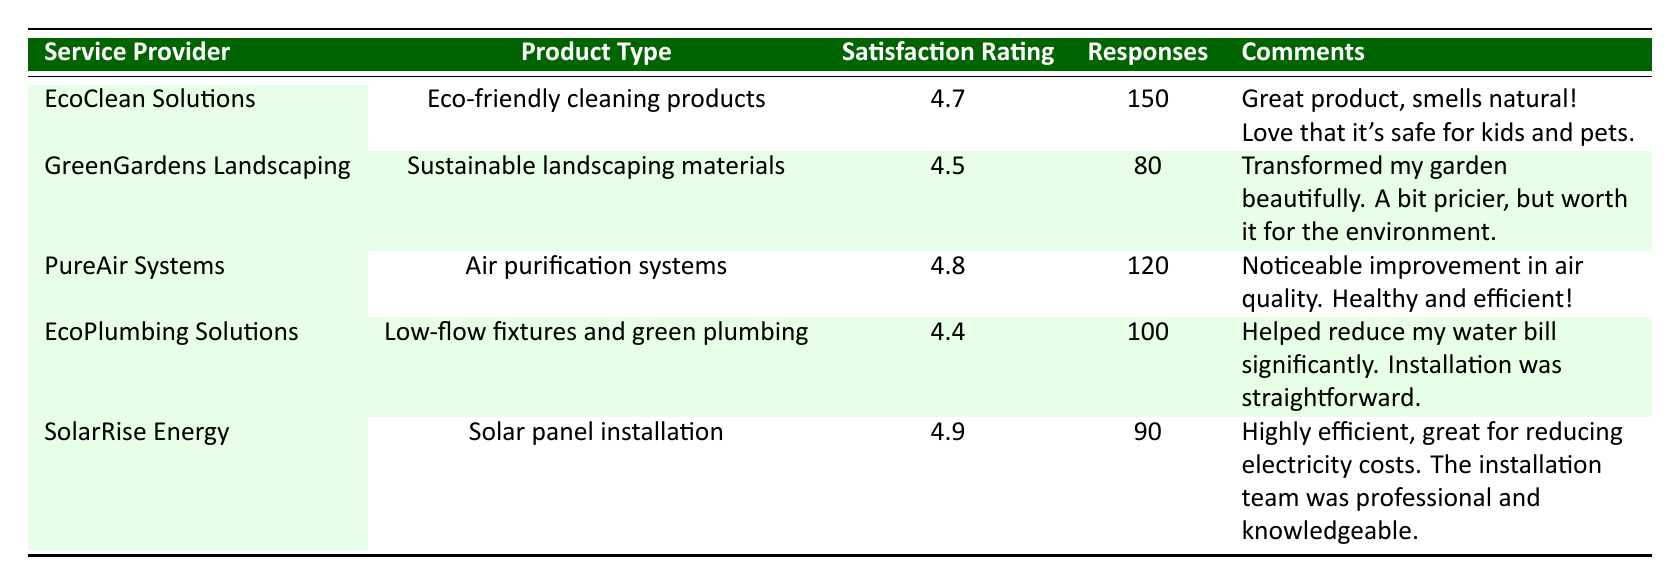What is the satisfaction rating for EcoClean Solutions? The table shows that EcoClean Solutions has a satisfaction rating of 4.7.
Answer: 4.7 Which product type has the highest satisfaction rating? According to the table, Solar panel installation by SolarRise Energy has the highest satisfaction rating of 4.9.
Answer: Solar panel installation How many total responses were collected for Eco-friendly cleaning products and Air purification systems combined? The total responses for Eco-friendly cleaning products (150) and Air purification systems (120) add up to 150 + 120 = 270.
Answer: 270 Is the satisfaction rating for EcoPlumbing Solutions above 4.5? The table indicates that EcoPlumbing Solutions has a satisfaction rating of 4.4, which is not above 4.5.
Answer: No What is the average satisfaction rating of all products listed in the table? To find the average, sum the satisfaction ratings (4.7 + 4.5 + 4.8 + 4.4 + 4.9 = 24.3) and divide by the number of products (5), resulting in an average satisfaction rating of 24.3 / 5 = 4.86.
Answer: 4.86 How many comments did customers provide for GreenGardens Landscaping? The table lists two comments provided by customers for GreenGardens Landscaping.
Answer: 2 Which service provider has both a high satisfaction rating and a high number of responses? Looking at the data, PureAir Systems has a satisfaction rating of 4.8 and 120 responses, indicating a balance between high ratings and feedback.
Answer: PureAir Systems Did customers rate SolarRise Energy lower than 4.5? The satisfaction rating for SolarRise Energy is shown to be 4.9, which means it was rated higher than 4.5.
Answer: No Which product type has the fewest responses according to the table? By examining the responses, Sustainable landscaping materials from GreenGardens Landscaping has the fewest responses with only 80.
Answer: Sustainable landscaping materials 